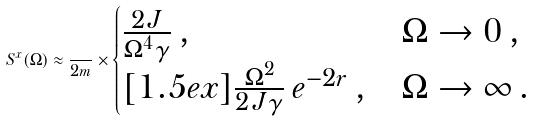<formula> <loc_0><loc_0><loc_500><loc_500>S ^ { x } ( \Omega ) \approx \frac { } { 2 m } \times \begin{cases} \frac { 2 J } { \Omega ^ { 4 } \gamma } \, , & \Omega \to 0 \, , \\ [ 1 . 5 e x ] \frac { \Omega ^ { 2 } } { 2 J \gamma } \, e ^ { - 2 r } \, , & \Omega \to \infty \, . \end{cases}</formula> 